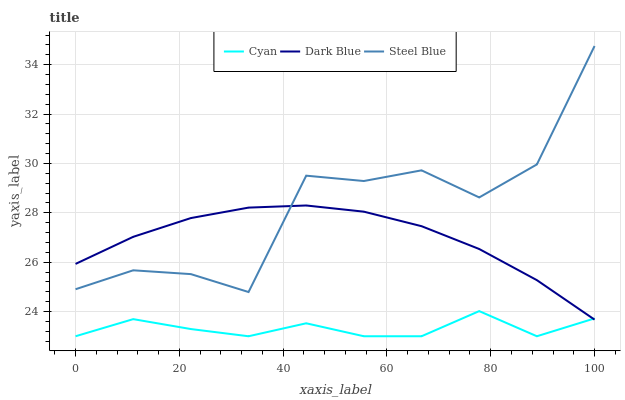Does Dark Blue have the minimum area under the curve?
Answer yes or no. No. Does Dark Blue have the maximum area under the curve?
Answer yes or no. No. Is Steel Blue the smoothest?
Answer yes or no. No. Is Dark Blue the roughest?
Answer yes or no. No. Does Dark Blue have the lowest value?
Answer yes or no. No. Does Dark Blue have the highest value?
Answer yes or no. No. Is Cyan less than Steel Blue?
Answer yes or no. Yes. Is Steel Blue greater than Cyan?
Answer yes or no. Yes. Does Cyan intersect Steel Blue?
Answer yes or no. No. 